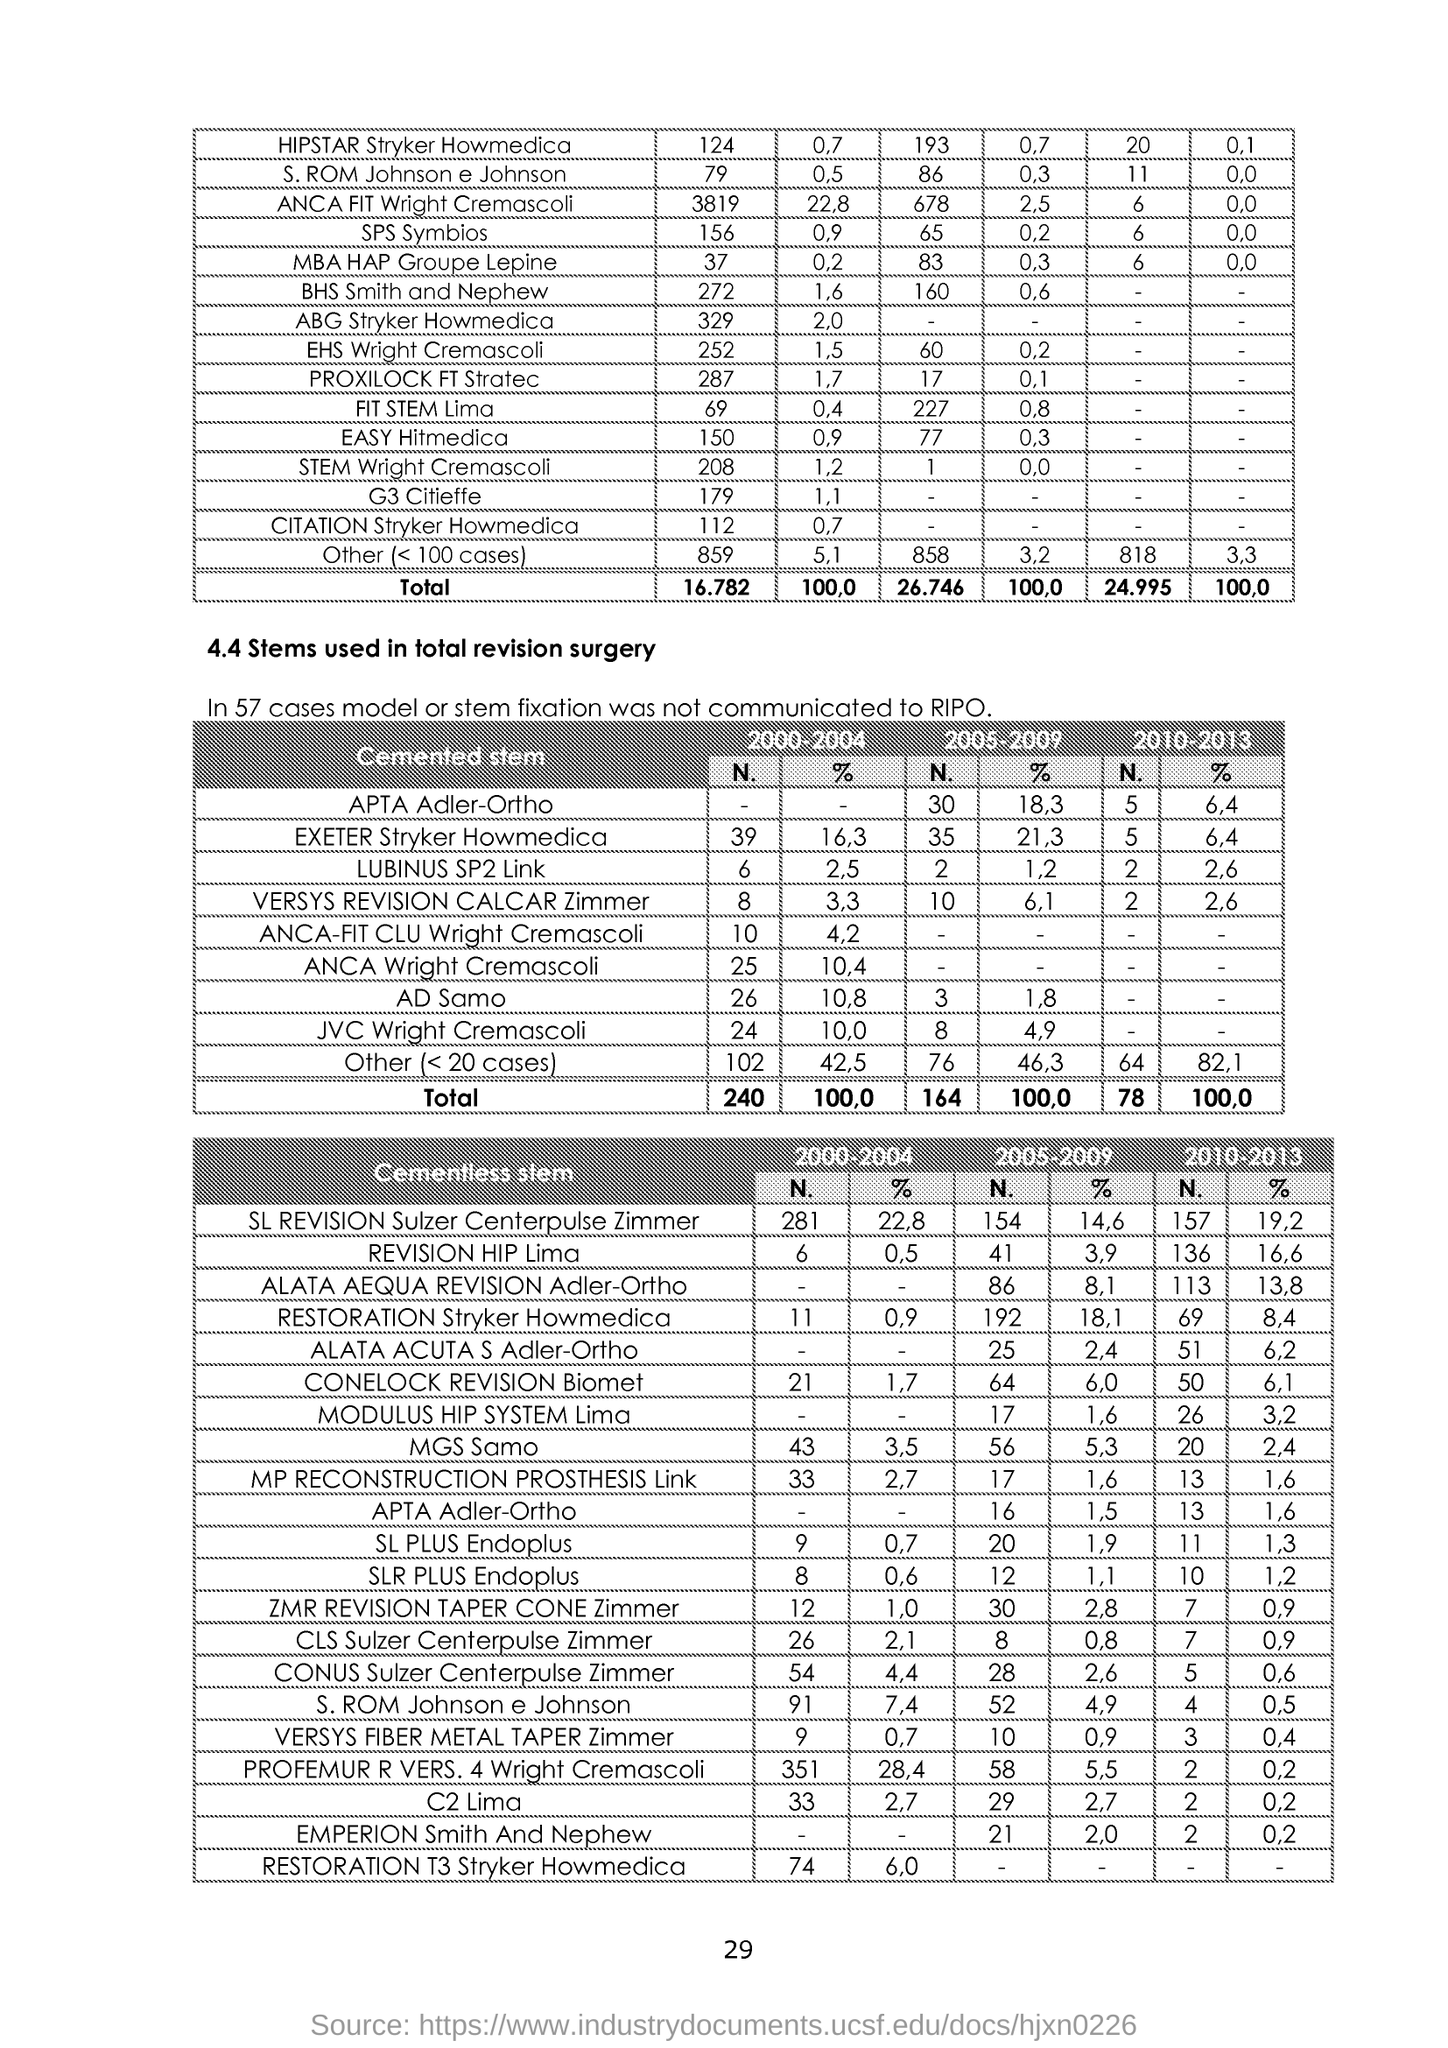List a handful of essential elements in this visual. The page number is 29. 